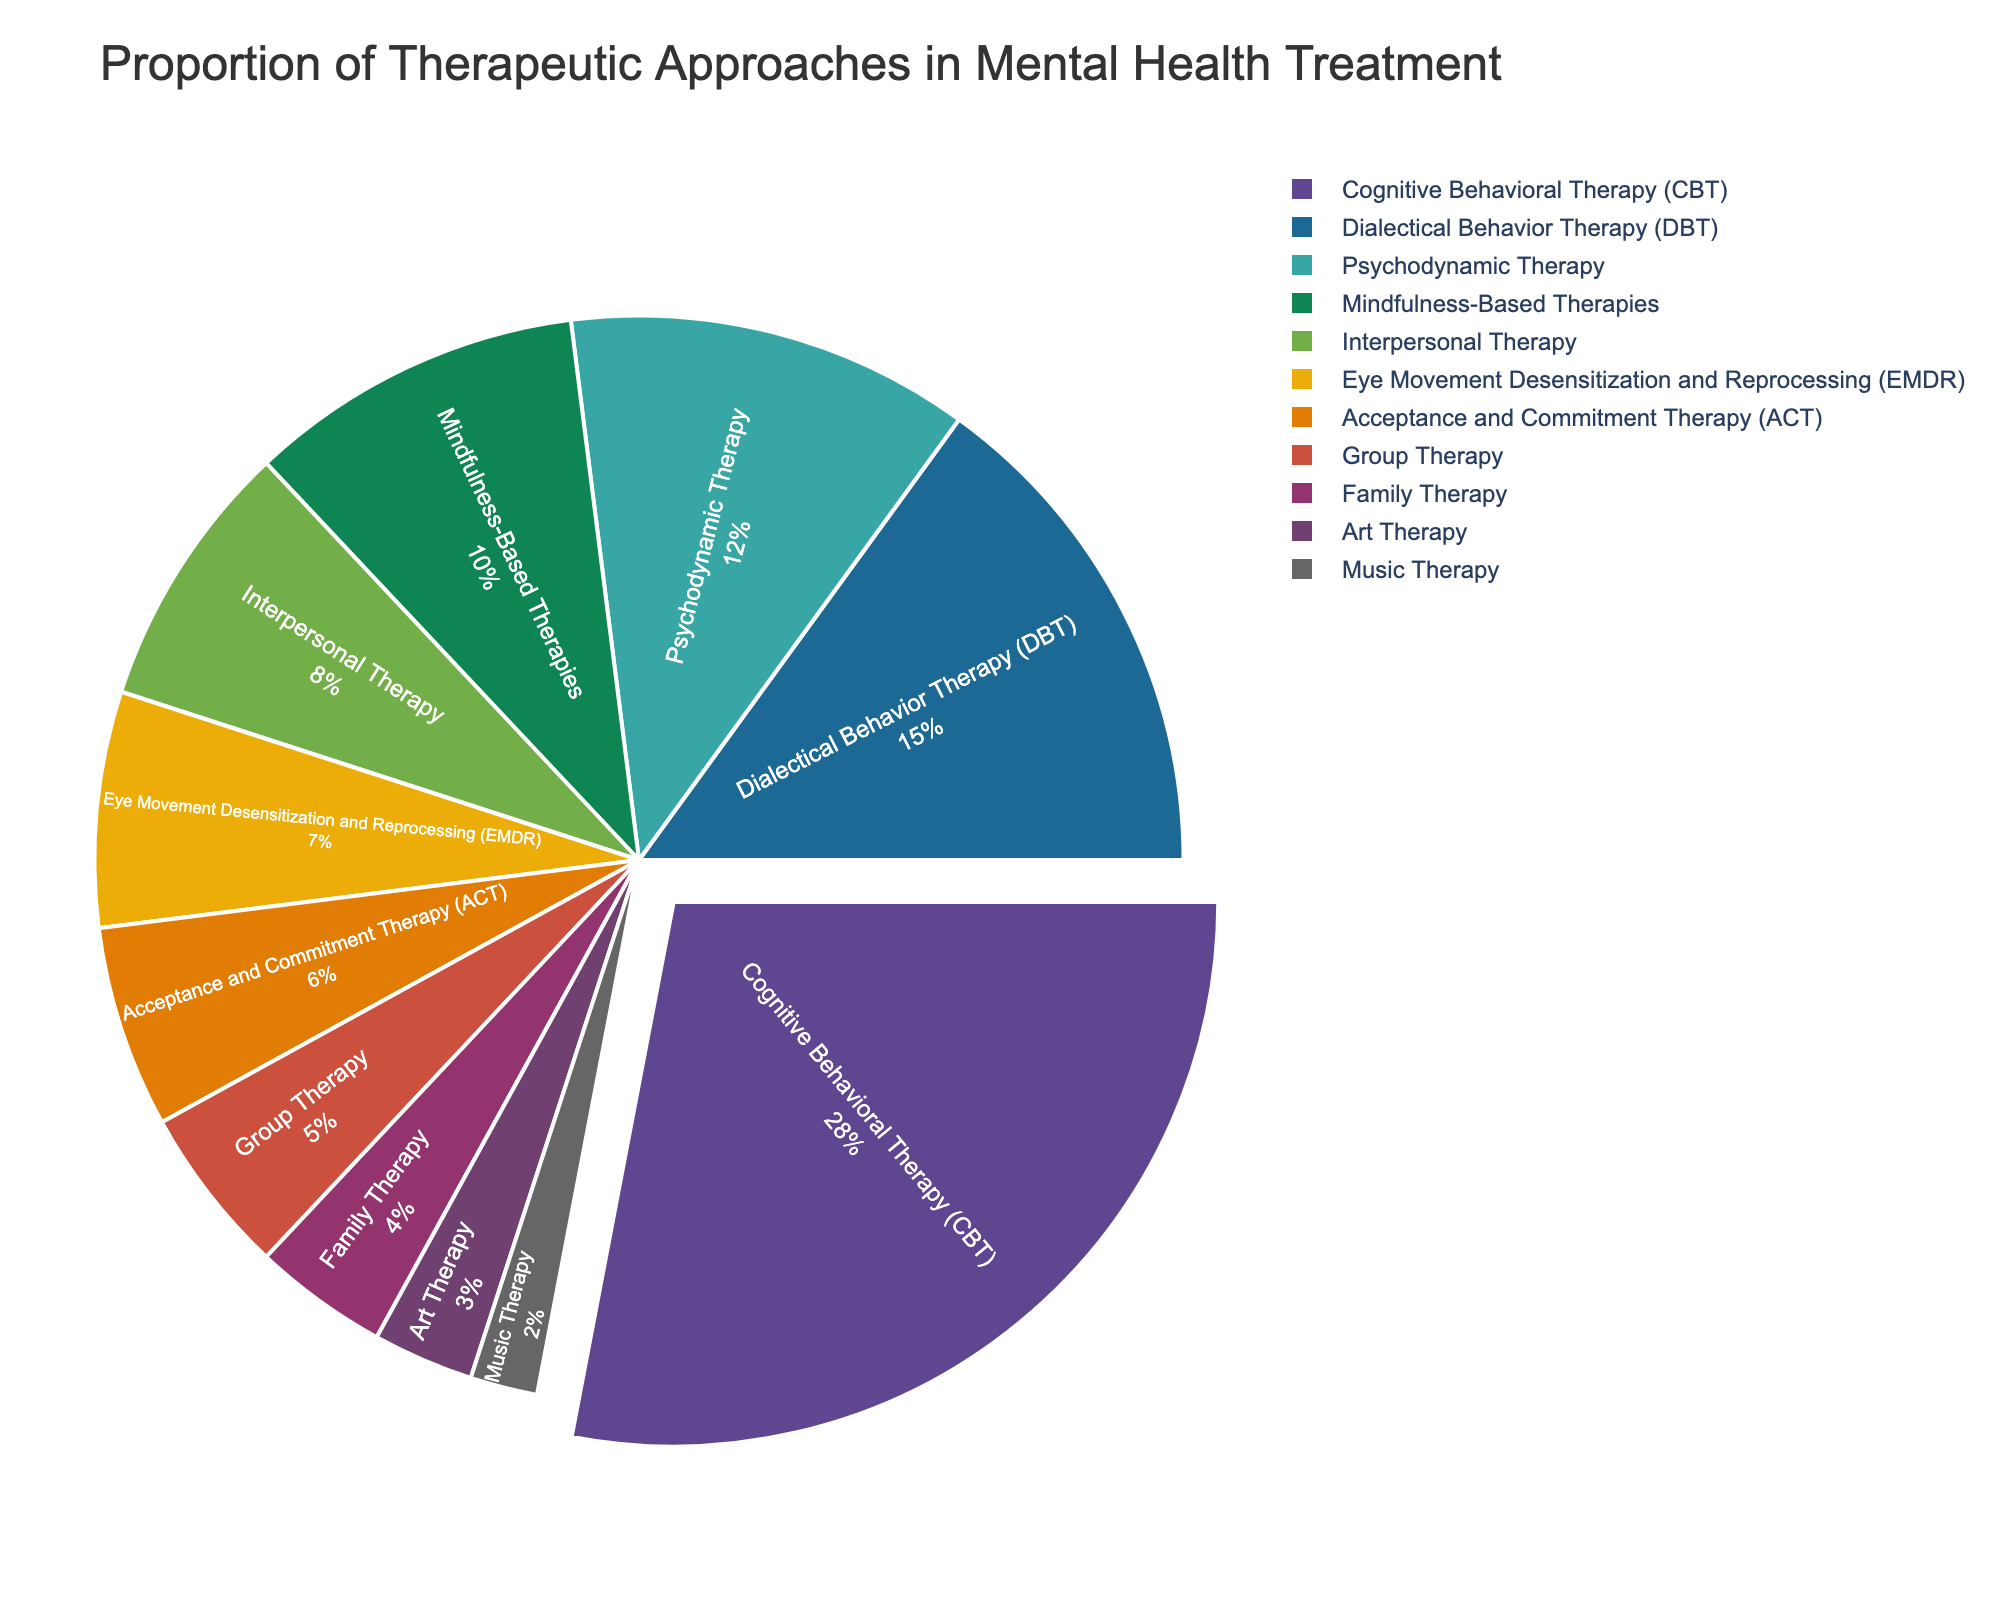What therapeutic approach occupies the largest proportion in the pie chart? Cognitive Behavioral Therapy (CBT) has the largest segment in the pie chart. The slice for CBT is the most pulled out and visually larger than the others.
Answer: Cognitive Behavioral Therapy (CBT) What is the combined percentage of Mindfulness-Based Therapies and Interpersonal Therapy? Add the percentages for Mindfulness-Based Therapies and Interpersonal Therapy: 10% + 8%.
Answer: 18% Which therapeutic approach has a smaller proportion, Family Therapy or Group Therapy? Family Therapy has a smaller segment compared to Group Therapy. By observing the pie chart, Family Therapy's slice is visually smaller than Group Therapy's.
Answer: Family Therapy What is the difference in percentage between EMDR and ACT? Subtract the percentage of ACT (6%) from the percentage of EMDR (7%).
Answer: 1% What is the total percentage of the three least represented therapeutic approaches? Add the percentages for Art Therapy, Music Therapy, and Family Therapy: 3% + 2% + 4%.
Answer: 9% Which therapeutic approaches have a proportion less than 10% and greater than 5%? Identify the approaches within this range: DBT, Psychodynamic Therapy, EMDR, and ACT are within this boundary when visually compared.
Answer: DBT, Psychodynamic Therapy, EMDR, ACT Are Dialectical Behavior Therapy (DBT) and Psychodynamic Therapy combined greater than or less than Cognitive Behavioral Therapy (CBT)? Add DBT (15%) and Psychodynamic Therapy (12%) and compare to CBT (28%). 27% < 28%.
Answer: Less than Which therapeutic approaches’ slices are red and green respectively? Observing the pie chart, match the red and green slices with their labels. Assume red is Mindfulness-Based Therapies and green is Psychodynamic Therapy.
Answer: Mindfulness-Based Therapies and Psychodynamic Therapy How many therapeutic approaches have a proportion of 5% or higher? Count all approaches with a 5% or bigger slice: CBT (28%), DBT (15%), Psychodynamic Therapy (12%), Mindfulness-Based Therapies (10%), Interpersonal Therapy (8%), EMDR (7%), ACT (6%), Group Therapy (5%).
Answer: 8 What is the average percentage of all therapeutic approaches shown? Sum all percentages and divide by the number of approaches: (28 + 15 + 12 + 10 + 8 + 7 + 6 + 5 + 4 + 3 + 2) / 11.
Answer: 9% 